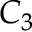<formula> <loc_0><loc_0><loc_500><loc_500>C _ { 3 }</formula> 